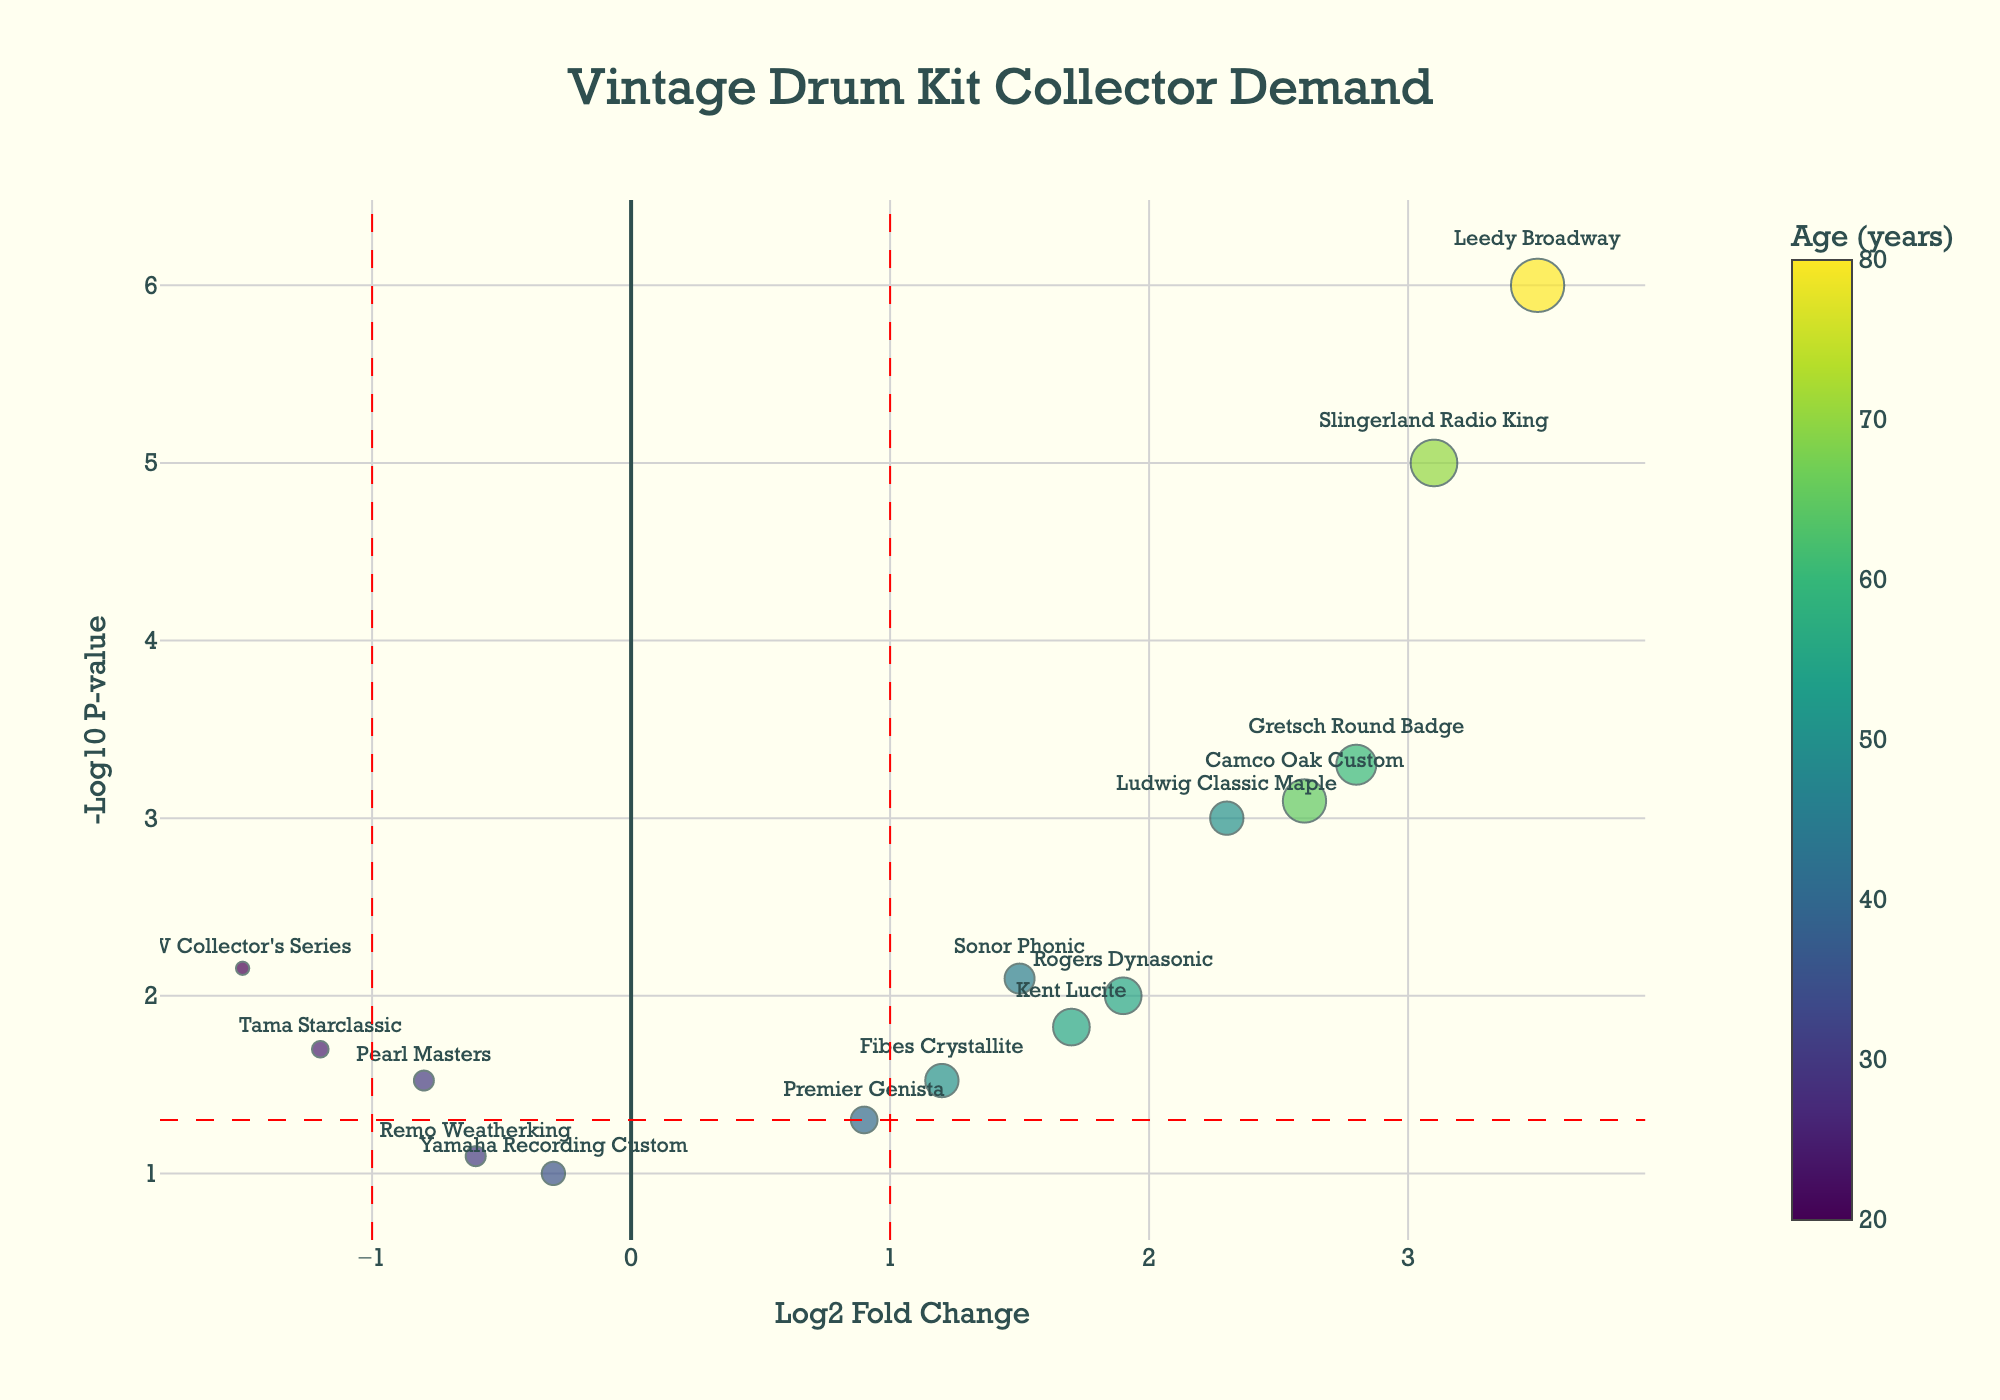What's the title of the plot? The title of the plot is located at the top of the figure and reads "Vintage Drum Kit Collector Demand".
Answer: Vintage Drum Kit Collector Demand What are the axes labels in the plot? The X-axis label is "Log2 Fold Change" and the Y-axis label is "-Log10 P-value". These labels are found along the respective axes.
Answer: Log2 Fold Change and -Log10 P-value How many drum kit styles are included in the plot? There are 15 data points in the plot, each representing a drum kit style. You can count the markers in the figure to determine this.
Answer: 15 Which drum kit style has the highest -log10(p-value)? The drum kit style with the highest -log10(p-value) is Leedy Broadway, as indicated by the point at the highest position on the Y-axis.
Answer: Leedy Broadway Which drum kit style has the lowest log2 fold change? The DW Collector's Series drum kit style has the lowest log2 fold change. It is the point furthest to the left on the X-axis.
Answer: DW Collector's Series How many drum kits are older than 60 years? To determine the number of drum kits older than 60 years, identify all points with marker sizes greater than 20 units (since the size is age/3). Only Gretsch Round Badge, Slingerland Radio King, and Leedy Broadway fit this criterion.
Answer: 3 Which drum kit styles have a log2 fold change greater than 1 and a -log10(p-value) greater than 1.3? To find these styles, look at points to the right of the 1 mark on the X-axis and above the red dashed line at approximately 1.3 on the Y-axis. Ludwig Classic Maple, Gretsch Round Badge, Slingerland Radio King, Sonor Phonic, Kent Lucite, and Camco Oak Custom meet these criteria.
Answer: Ludwig Classic Maple, Gretsch Round Badge, Slingerland Radio King, Sonor Phonic, Kent Lucite, and Camco Oak Custom Which drum kits show a significant decrease in collector demand? Kits shown as having a significant decrease in demand will have a log2 fold change less than -1 and a -log10(p-value) greater than 1.3 (above the horizontal line). Pearl Masters, Tama Starclassic, and DW Collector's Series meet these criteria.
Answer: Pearl Masters, Tama Starclassic, and DW Collector's Series What's the oldest drum kit style with a significant increase in collector demand? The oldest style with a significant increase (log2 fold change > 1 and -log10(p-value) > 1.3) is Leedy Broadway, which is obvious from its position and its age (80 years).
Answer: Leedy Broadway Is there any relationship observed between the age of drum kits and collector demand from this plot? By observing the colors and marker sizes, older drum kits (indicated by larger, yellow to green markers) tend to show higher collector demand (right side of the X-axis and higher Y-axis values).
Answer: Older drum kits tend to show higher collector demand 